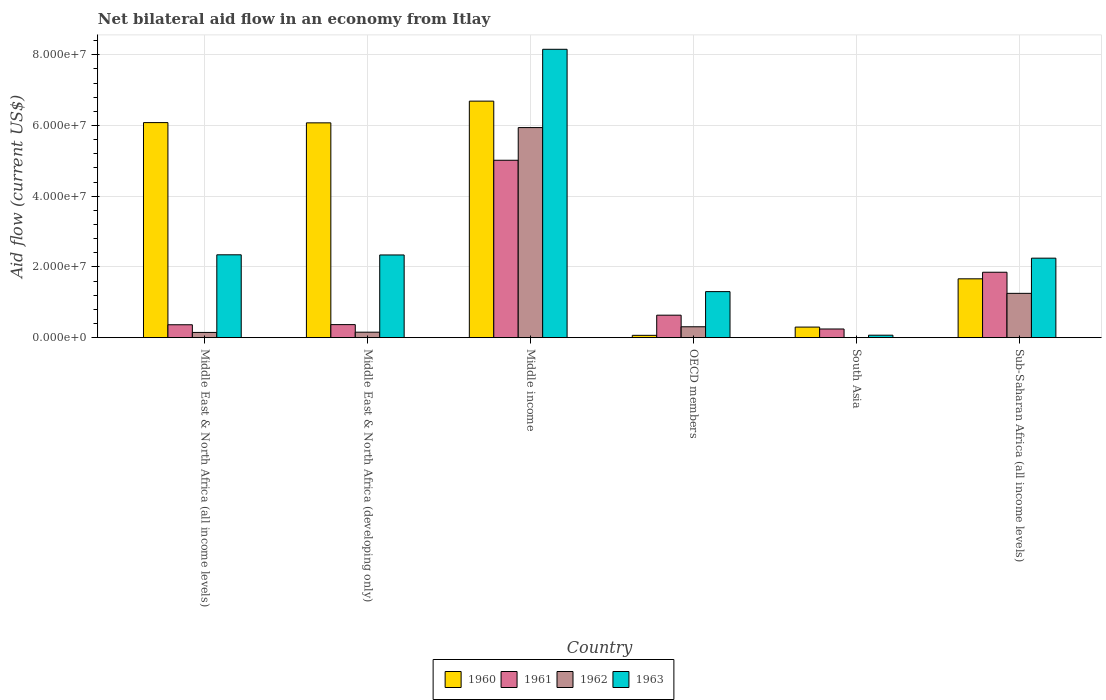How many different coloured bars are there?
Your response must be concise. 4. Are the number of bars per tick equal to the number of legend labels?
Your answer should be very brief. No. Are the number of bars on each tick of the X-axis equal?
Offer a terse response. No. How many bars are there on the 5th tick from the left?
Your answer should be very brief. 3. How many bars are there on the 6th tick from the right?
Offer a terse response. 4. What is the label of the 3rd group of bars from the left?
Give a very brief answer. Middle income. In how many cases, is the number of bars for a given country not equal to the number of legend labels?
Make the answer very short. 1. What is the net bilateral aid flow in 1960 in Middle East & North Africa (all income levels)?
Give a very brief answer. 6.08e+07. Across all countries, what is the maximum net bilateral aid flow in 1962?
Ensure brevity in your answer.  5.94e+07. In which country was the net bilateral aid flow in 1962 maximum?
Offer a very short reply. Middle income. What is the total net bilateral aid flow in 1961 in the graph?
Your answer should be compact. 8.48e+07. What is the difference between the net bilateral aid flow in 1960 in Middle income and that in South Asia?
Offer a very short reply. 6.39e+07. What is the difference between the net bilateral aid flow in 1961 in South Asia and the net bilateral aid flow in 1963 in Middle East & North Africa (developing only)?
Make the answer very short. -2.09e+07. What is the average net bilateral aid flow in 1961 per country?
Provide a succinct answer. 1.41e+07. What is the difference between the net bilateral aid flow of/in 1962 and net bilateral aid flow of/in 1963 in OECD members?
Keep it short and to the point. -9.94e+06. In how many countries, is the net bilateral aid flow in 1963 greater than 12000000 US$?
Make the answer very short. 5. What is the ratio of the net bilateral aid flow in 1961 in Middle East & North Africa (all income levels) to that in OECD members?
Your response must be concise. 0.57. What is the difference between the highest and the second highest net bilateral aid flow in 1960?
Give a very brief answer. 6.07e+06. What is the difference between the highest and the lowest net bilateral aid flow in 1961?
Provide a short and direct response. 4.77e+07. Is the sum of the net bilateral aid flow in 1961 in Middle income and Sub-Saharan Africa (all income levels) greater than the maximum net bilateral aid flow in 1963 across all countries?
Your answer should be very brief. No. Is it the case that in every country, the sum of the net bilateral aid flow in 1963 and net bilateral aid flow in 1961 is greater than the sum of net bilateral aid flow in 1962 and net bilateral aid flow in 1960?
Make the answer very short. No. Is it the case that in every country, the sum of the net bilateral aid flow in 1960 and net bilateral aid flow in 1962 is greater than the net bilateral aid flow in 1963?
Ensure brevity in your answer.  No. How many bars are there?
Offer a terse response. 23. Are all the bars in the graph horizontal?
Keep it short and to the point. No. What is the difference between two consecutive major ticks on the Y-axis?
Your answer should be compact. 2.00e+07. Are the values on the major ticks of Y-axis written in scientific E-notation?
Your answer should be very brief. Yes. Where does the legend appear in the graph?
Offer a terse response. Bottom center. How many legend labels are there?
Your answer should be very brief. 4. What is the title of the graph?
Give a very brief answer. Net bilateral aid flow in an economy from Itlay. What is the Aid flow (current US$) in 1960 in Middle East & North Africa (all income levels)?
Ensure brevity in your answer.  6.08e+07. What is the Aid flow (current US$) of 1961 in Middle East & North Africa (all income levels)?
Provide a succinct answer. 3.65e+06. What is the Aid flow (current US$) in 1962 in Middle East & North Africa (all income levels)?
Your answer should be compact. 1.48e+06. What is the Aid flow (current US$) of 1963 in Middle East & North Africa (all income levels)?
Keep it short and to the point. 2.34e+07. What is the Aid flow (current US$) in 1960 in Middle East & North Africa (developing only)?
Offer a terse response. 6.08e+07. What is the Aid flow (current US$) of 1961 in Middle East & North Africa (developing only)?
Keep it short and to the point. 3.69e+06. What is the Aid flow (current US$) of 1962 in Middle East & North Africa (developing only)?
Provide a short and direct response. 1.55e+06. What is the Aid flow (current US$) in 1963 in Middle East & North Africa (developing only)?
Provide a short and direct response. 2.34e+07. What is the Aid flow (current US$) in 1960 in Middle income?
Give a very brief answer. 6.69e+07. What is the Aid flow (current US$) of 1961 in Middle income?
Ensure brevity in your answer.  5.02e+07. What is the Aid flow (current US$) in 1962 in Middle income?
Keep it short and to the point. 5.94e+07. What is the Aid flow (current US$) of 1963 in Middle income?
Your answer should be compact. 8.16e+07. What is the Aid flow (current US$) of 1961 in OECD members?
Ensure brevity in your answer.  6.36e+06. What is the Aid flow (current US$) in 1962 in OECD members?
Your response must be concise. 3.08e+06. What is the Aid flow (current US$) of 1963 in OECD members?
Ensure brevity in your answer.  1.30e+07. What is the Aid flow (current US$) in 1960 in South Asia?
Keep it short and to the point. 2.99e+06. What is the Aid flow (current US$) of 1961 in South Asia?
Your response must be concise. 2.45e+06. What is the Aid flow (current US$) of 1962 in South Asia?
Keep it short and to the point. 0. What is the Aid flow (current US$) of 1960 in Sub-Saharan Africa (all income levels)?
Ensure brevity in your answer.  1.66e+07. What is the Aid flow (current US$) of 1961 in Sub-Saharan Africa (all income levels)?
Provide a short and direct response. 1.85e+07. What is the Aid flow (current US$) of 1962 in Sub-Saharan Africa (all income levels)?
Provide a short and direct response. 1.25e+07. What is the Aid flow (current US$) in 1963 in Sub-Saharan Africa (all income levels)?
Your answer should be compact. 2.25e+07. Across all countries, what is the maximum Aid flow (current US$) in 1960?
Your response must be concise. 6.69e+07. Across all countries, what is the maximum Aid flow (current US$) of 1961?
Provide a short and direct response. 5.02e+07. Across all countries, what is the maximum Aid flow (current US$) of 1962?
Provide a short and direct response. 5.94e+07. Across all countries, what is the maximum Aid flow (current US$) in 1963?
Your answer should be very brief. 8.16e+07. Across all countries, what is the minimum Aid flow (current US$) of 1961?
Provide a succinct answer. 2.45e+06. Across all countries, what is the minimum Aid flow (current US$) in 1962?
Give a very brief answer. 0. What is the total Aid flow (current US$) of 1960 in the graph?
Offer a very short reply. 2.09e+08. What is the total Aid flow (current US$) in 1961 in the graph?
Your answer should be very brief. 8.48e+07. What is the total Aid flow (current US$) of 1962 in the graph?
Your answer should be very brief. 7.80e+07. What is the total Aid flow (current US$) of 1963 in the graph?
Your answer should be very brief. 1.65e+08. What is the difference between the Aid flow (current US$) of 1960 in Middle East & North Africa (all income levels) and that in Middle East & North Africa (developing only)?
Provide a succinct answer. 7.00e+04. What is the difference between the Aid flow (current US$) in 1962 in Middle East & North Africa (all income levels) and that in Middle East & North Africa (developing only)?
Your answer should be compact. -7.00e+04. What is the difference between the Aid flow (current US$) of 1963 in Middle East & North Africa (all income levels) and that in Middle East & North Africa (developing only)?
Provide a succinct answer. 4.00e+04. What is the difference between the Aid flow (current US$) of 1960 in Middle East & North Africa (all income levels) and that in Middle income?
Offer a terse response. -6.07e+06. What is the difference between the Aid flow (current US$) of 1961 in Middle East & North Africa (all income levels) and that in Middle income?
Provide a succinct answer. -4.65e+07. What is the difference between the Aid flow (current US$) in 1962 in Middle East & North Africa (all income levels) and that in Middle income?
Your response must be concise. -5.79e+07. What is the difference between the Aid flow (current US$) in 1963 in Middle East & North Africa (all income levels) and that in Middle income?
Offer a terse response. -5.81e+07. What is the difference between the Aid flow (current US$) of 1960 in Middle East & North Africa (all income levels) and that in OECD members?
Give a very brief answer. 6.02e+07. What is the difference between the Aid flow (current US$) of 1961 in Middle East & North Africa (all income levels) and that in OECD members?
Give a very brief answer. -2.71e+06. What is the difference between the Aid flow (current US$) of 1962 in Middle East & North Africa (all income levels) and that in OECD members?
Your answer should be compact. -1.60e+06. What is the difference between the Aid flow (current US$) of 1963 in Middle East & North Africa (all income levels) and that in OECD members?
Keep it short and to the point. 1.04e+07. What is the difference between the Aid flow (current US$) in 1960 in Middle East & North Africa (all income levels) and that in South Asia?
Your answer should be compact. 5.78e+07. What is the difference between the Aid flow (current US$) in 1961 in Middle East & North Africa (all income levels) and that in South Asia?
Your answer should be compact. 1.20e+06. What is the difference between the Aid flow (current US$) in 1963 in Middle East & North Africa (all income levels) and that in South Asia?
Keep it short and to the point. 2.27e+07. What is the difference between the Aid flow (current US$) in 1960 in Middle East & North Africa (all income levels) and that in Sub-Saharan Africa (all income levels)?
Your response must be concise. 4.42e+07. What is the difference between the Aid flow (current US$) of 1961 in Middle East & North Africa (all income levels) and that in Sub-Saharan Africa (all income levels)?
Your answer should be compact. -1.48e+07. What is the difference between the Aid flow (current US$) in 1962 in Middle East & North Africa (all income levels) and that in Sub-Saharan Africa (all income levels)?
Keep it short and to the point. -1.10e+07. What is the difference between the Aid flow (current US$) in 1963 in Middle East & North Africa (all income levels) and that in Sub-Saharan Africa (all income levels)?
Offer a terse response. 9.50e+05. What is the difference between the Aid flow (current US$) in 1960 in Middle East & North Africa (developing only) and that in Middle income?
Your answer should be compact. -6.14e+06. What is the difference between the Aid flow (current US$) in 1961 in Middle East & North Africa (developing only) and that in Middle income?
Your answer should be very brief. -4.65e+07. What is the difference between the Aid flow (current US$) in 1962 in Middle East & North Africa (developing only) and that in Middle income?
Your response must be concise. -5.79e+07. What is the difference between the Aid flow (current US$) of 1963 in Middle East & North Africa (developing only) and that in Middle income?
Make the answer very short. -5.82e+07. What is the difference between the Aid flow (current US$) of 1960 in Middle East & North Africa (developing only) and that in OECD members?
Ensure brevity in your answer.  6.01e+07. What is the difference between the Aid flow (current US$) in 1961 in Middle East & North Africa (developing only) and that in OECD members?
Keep it short and to the point. -2.67e+06. What is the difference between the Aid flow (current US$) of 1962 in Middle East & North Africa (developing only) and that in OECD members?
Give a very brief answer. -1.53e+06. What is the difference between the Aid flow (current US$) in 1963 in Middle East & North Africa (developing only) and that in OECD members?
Ensure brevity in your answer.  1.04e+07. What is the difference between the Aid flow (current US$) of 1960 in Middle East & North Africa (developing only) and that in South Asia?
Ensure brevity in your answer.  5.78e+07. What is the difference between the Aid flow (current US$) of 1961 in Middle East & North Africa (developing only) and that in South Asia?
Ensure brevity in your answer.  1.24e+06. What is the difference between the Aid flow (current US$) in 1963 in Middle East & North Africa (developing only) and that in South Asia?
Your response must be concise. 2.27e+07. What is the difference between the Aid flow (current US$) of 1960 in Middle East & North Africa (developing only) and that in Sub-Saharan Africa (all income levels)?
Your answer should be compact. 4.41e+07. What is the difference between the Aid flow (current US$) in 1961 in Middle East & North Africa (developing only) and that in Sub-Saharan Africa (all income levels)?
Provide a succinct answer. -1.48e+07. What is the difference between the Aid flow (current US$) in 1962 in Middle East & North Africa (developing only) and that in Sub-Saharan Africa (all income levels)?
Keep it short and to the point. -1.10e+07. What is the difference between the Aid flow (current US$) in 1963 in Middle East & North Africa (developing only) and that in Sub-Saharan Africa (all income levels)?
Offer a terse response. 9.10e+05. What is the difference between the Aid flow (current US$) of 1960 in Middle income and that in OECD members?
Make the answer very short. 6.62e+07. What is the difference between the Aid flow (current US$) of 1961 in Middle income and that in OECD members?
Offer a very short reply. 4.38e+07. What is the difference between the Aid flow (current US$) of 1962 in Middle income and that in OECD members?
Provide a short and direct response. 5.63e+07. What is the difference between the Aid flow (current US$) of 1963 in Middle income and that in OECD members?
Your response must be concise. 6.85e+07. What is the difference between the Aid flow (current US$) in 1960 in Middle income and that in South Asia?
Give a very brief answer. 6.39e+07. What is the difference between the Aid flow (current US$) in 1961 in Middle income and that in South Asia?
Give a very brief answer. 4.77e+07. What is the difference between the Aid flow (current US$) of 1963 in Middle income and that in South Asia?
Provide a short and direct response. 8.08e+07. What is the difference between the Aid flow (current US$) of 1960 in Middle income and that in Sub-Saharan Africa (all income levels)?
Keep it short and to the point. 5.02e+07. What is the difference between the Aid flow (current US$) in 1961 in Middle income and that in Sub-Saharan Africa (all income levels)?
Offer a terse response. 3.17e+07. What is the difference between the Aid flow (current US$) of 1962 in Middle income and that in Sub-Saharan Africa (all income levels)?
Offer a terse response. 4.69e+07. What is the difference between the Aid flow (current US$) in 1963 in Middle income and that in Sub-Saharan Africa (all income levels)?
Offer a very short reply. 5.91e+07. What is the difference between the Aid flow (current US$) in 1960 in OECD members and that in South Asia?
Keep it short and to the point. -2.33e+06. What is the difference between the Aid flow (current US$) of 1961 in OECD members and that in South Asia?
Make the answer very short. 3.91e+06. What is the difference between the Aid flow (current US$) of 1963 in OECD members and that in South Asia?
Offer a terse response. 1.23e+07. What is the difference between the Aid flow (current US$) in 1960 in OECD members and that in Sub-Saharan Africa (all income levels)?
Give a very brief answer. -1.60e+07. What is the difference between the Aid flow (current US$) of 1961 in OECD members and that in Sub-Saharan Africa (all income levels)?
Your response must be concise. -1.21e+07. What is the difference between the Aid flow (current US$) in 1962 in OECD members and that in Sub-Saharan Africa (all income levels)?
Ensure brevity in your answer.  -9.45e+06. What is the difference between the Aid flow (current US$) of 1963 in OECD members and that in Sub-Saharan Africa (all income levels)?
Your answer should be very brief. -9.46e+06. What is the difference between the Aid flow (current US$) in 1960 in South Asia and that in Sub-Saharan Africa (all income levels)?
Keep it short and to the point. -1.36e+07. What is the difference between the Aid flow (current US$) in 1961 in South Asia and that in Sub-Saharan Africa (all income levels)?
Your answer should be compact. -1.60e+07. What is the difference between the Aid flow (current US$) of 1963 in South Asia and that in Sub-Saharan Africa (all income levels)?
Ensure brevity in your answer.  -2.18e+07. What is the difference between the Aid flow (current US$) in 1960 in Middle East & North Africa (all income levels) and the Aid flow (current US$) in 1961 in Middle East & North Africa (developing only)?
Provide a short and direct response. 5.71e+07. What is the difference between the Aid flow (current US$) of 1960 in Middle East & North Africa (all income levels) and the Aid flow (current US$) of 1962 in Middle East & North Africa (developing only)?
Provide a short and direct response. 5.93e+07. What is the difference between the Aid flow (current US$) in 1960 in Middle East & North Africa (all income levels) and the Aid flow (current US$) in 1963 in Middle East & North Africa (developing only)?
Keep it short and to the point. 3.74e+07. What is the difference between the Aid flow (current US$) in 1961 in Middle East & North Africa (all income levels) and the Aid flow (current US$) in 1962 in Middle East & North Africa (developing only)?
Give a very brief answer. 2.10e+06. What is the difference between the Aid flow (current US$) in 1961 in Middle East & North Africa (all income levels) and the Aid flow (current US$) in 1963 in Middle East & North Africa (developing only)?
Make the answer very short. -1.97e+07. What is the difference between the Aid flow (current US$) of 1962 in Middle East & North Africa (all income levels) and the Aid flow (current US$) of 1963 in Middle East & North Africa (developing only)?
Provide a succinct answer. -2.19e+07. What is the difference between the Aid flow (current US$) in 1960 in Middle East & North Africa (all income levels) and the Aid flow (current US$) in 1961 in Middle income?
Your response must be concise. 1.06e+07. What is the difference between the Aid flow (current US$) of 1960 in Middle East & North Africa (all income levels) and the Aid flow (current US$) of 1962 in Middle income?
Your answer should be very brief. 1.41e+06. What is the difference between the Aid flow (current US$) of 1960 in Middle East & North Africa (all income levels) and the Aid flow (current US$) of 1963 in Middle income?
Provide a succinct answer. -2.07e+07. What is the difference between the Aid flow (current US$) of 1961 in Middle East & North Africa (all income levels) and the Aid flow (current US$) of 1962 in Middle income?
Your answer should be very brief. -5.58e+07. What is the difference between the Aid flow (current US$) in 1961 in Middle East & North Africa (all income levels) and the Aid flow (current US$) in 1963 in Middle income?
Make the answer very short. -7.79e+07. What is the difference between the Aid flow (current US$) of 1962 in Middle East & North Africa (all income levels) and the Aid flow (current US$) of 1963 in Middle income?
Your answer should be compact. -8.01e+07. What is the difference between the Aid flow (current US$) of 1960 in Middle East & North Africa (all income levels) and the Aid flow (current US$) of 1961 in OECD members?
Keep it short and to the point. 5.45e+07. What is the difference between the Aid flow (current US$) of 1960 in Middle East & North Africa (all income levels) and the Aid flow (current US$) of 1962 in OECD members?
Your answer should be very brief. 5.77e+07. What is the difference between the Aid flow (current US$) of 1960 in Middle East & North Africa (all income levels) and the Aid flow (current US$) of 1963 in OECD members?
Offer a very short reply. 4.78e+07. What is the difference between the Aid flow (current US$) of 1961 in Middle East & North Africa (all income levels) and the Aid flow (current US$) of 1962 in OECD members?
Offer a very short reply. 5.70e+05. What is the difference between the Aid flow (current US$) in 1961 in Middle East & North Africa (all income levels) and the Aid flow (current US$) in 1963 in OECD members?
Make the answer very short. -9.37e+06. What is the difference between the Aid flow (current US$) of 1962 in Middle East & North Africa (all income levels) and the Aid flow (current US$) of 1963 in OECD members?
Your answer should be very brief. -1.15e+07. What is the difference between the Aid flow (current US$) in 1960 in Middle East & North Africa (all income levels) and the Aid flow (current US$) in 1961 in South Asia?
Provide a succinct answer. 5.84e+07. What is the difference between the Aid flow (current US$) of 1960 in Middle East & North Africa (all income levels) and the Aid flow (current US$) of 1963 in South Asia?
Offer a very short reply. 6.01e+07. What is the difference between the Aid flow (current US$) in 1961 in Middle East & North Africa (all income levels) and the Aid flow (current US$) in 1963 in South Asia?
Offer a terse response. 2.95e+06. What is the difference between the Aid flow (current US$) in 1962 in Middle East & North Africa (all income levels) and the Aid flow (current US$) in 1963 in South Asia?
Make the answer very short. 7.80e+05. What is the difference between the Aid flow (current US$) in 1960 in Middle East & North Africa (all income levels) and the Aid flow (current US$) in 1961 in Sub-Saharan Africa (all income levels)?
Give a very brief answer. 4.23e+07. What is the difference between the Aid flow (current US$) in 1960 in Middle East & North Africa (all income levels) and the Aid flow (current US$) in 1962 in Sub-Saharan Africa (all income levels)?
Your answer should be very brief. 4.83e+07. What is the difference between the Aid flow (current US$) in 1960 in Middle East & North Africa (all income levels) and the Aid flow (current US$) in 1963 in Sub-Saharan Africa (all income levels)?
Offer a very short reply. 3.83e+07. What is the difference between the Aid flow (current US$) of 1961 in Middle East & North Africa (all income levels) and the Aid flow (current US$) of 1962 in Sub-Saharan Africa (all income levels)?
Your answer should be very brief. -8.88e+06. What is the difference between the Aid flow (current US$) in 1961 in Middle East & North Africa (all income levels) and the Aid flow (current US$) in 1963 in Sub-Saharan Africa (all income levels)?
Give a very brief answer. -1.88e+07. What is the difference between the Aid flow (current US$) in 1962 in Middle East & North Africa (all income levels) and the Aid flow (current US$) in 1963 in Sub-Saharan Africa (all income levels)?
Provide a succinct answer. -2.10e+07. What is the difference between the Aid flow (current US$) of 1960 in Middle East & North Africa (developing only) and the Aid flow (current US$) of 1961 in Middle income?
Provide a short and direct response. 1.06e+07. What is the difference between the Aid flow (current US$) in 1960 in Middle East & North Africa (developing only) and the Aid flow (current US$) in 1962 in Middle income?
Your answer should be compact. 1.34e+06. What is the difference between the Aid flow (current US$) of 1960 in Middle East & North Africa (developing only) and the Aid flow (current US$) of 1963 in Middle income?
Ensure brevity in your answer.  -2.08e+07. What is the difference between the Aid flow (current US$) of 1961 in Middle East & North Africa (developing only) and the Aid flow (current US$) of 1962 in Middle income?
Your response must be concise. -5.57e+07. What is the difference between the Aid flow (current US$) in 1961 in Middle East & North Africa (developing only) and the Aid flow (current US$) in 1963 in Middle income?
Keep it short and to the point. -7.79e+07. What is the difference between the Aid flow (current US$) in 1962 in Middle East & North Africa (developing only) and the Aid flow (current US$) in 1963 in Middle income?
Your response must be concise. -8.00e+07. What is the difference between the Aid flow (current US$) in 1960 in Middle East & North Africa (developing only) and the Aid flow (current US$) in 1961 in OECD members?
Give a very brief answer. 5.44e+07. What is the difference between the Aid flow (current US$) in 1960 in Middle East & North Africa (developing only) and the Aid flow (current US$) in 1962 in OECD members?
Provide a succinct answer. 5.77e+07. What is the difference between the Aid flow (current US$) in 1960 in Middle East & North Africa (developing only) and the Aid flow (current US$) in 1963 in OECD members?
Your answer should be compact. 4.77e+07. What is the difference between the Aid flow (current US$) of 1961 in Middle East & North Africa (developing only) and the Aid flow (current US$) of 1962 in OECD members?
Ensure brevity in your answer.  6.10e+05. What is the difference between the Aid flow (current US$) in 1961 in Middle East & North Africa (developing only) and the Aid flow (current US$) in 1963 in OECD members?
Make the answer very short. -9.33e+06. What is the difference between the Aid flow (current US$) of 1962 in Middle East & North Africa (developing only) and the Aid flow (current US$) of 1963 in OECD members?
Your answer should be very brief. -1.15e+07. What is the difference between the Aid flow (current US$) of 1960 in Middle East & North Africa (developing only) and the Aid flow (current US$) of 1961 in South Asia?
Your answer should be very brief. 5.83e+07. What is the difference between the Aid flow (current US$) in 1960 in Middle East & North Africa (developing only) and the Aid flow (current US$) in 1963 in South Asia?
Provide a short and direct response. 6.00e+07. What is the difference between the Aid flow (current US$) of 1961 in Middle East & North Africa (developing only) and the Aid flow (current US$) of 1963 in South Asia?
Make the answer very short. 2.99e+06. What is the difference between the Aid flow (current US$) in 1962 in Middle East & North Africa (developing only) and the Aid flow (current US$) in 1963 in South Asia?
Make the answer very short. 8.50e+05. What is the difference between the Aid flow (current US$) in 1960 in Middle East & North Africa (developing only) and the Aid flow (current US$) in 1961 in Sub-Saharan Africa (all income levels)?
Your answer should be very brief. 4.22e+07. What is the difference between the Aid flow (current US$) of 1960 in Middle East & North Africa (developing only) and the Aid flow (current US$) of 1962 in Sub-Saharan Africa (all income levels)?
Offer a very short reply. 4.82e+07. What is the difference between the Aid flow (current US$) of 1960 in Middle East & North Africa (developing only) and the Aid flow (current US$) of 1963 in Sub-Saharan Africa (all income levels)?
Make the answer very short. 3.83e+07. What is the difference between the Aid flow (current US$) of 1961 in Middle East & North Africa (developing only) and the Aid flow (current US$) of 1962 in Sub-Saharan Africa (all income levels)?
Your answer should be very brief. -8.84e+06. What is the difference between the Aid flow (current US$) of 1961 in Middle East & North Africa (developing only) and the Aid flow (current US$) of 1963 in Sub-Saharan Africa (all income levels)?
Give a very brief answer. -1.88e+07. What is the difference between the Aid flow (current US$) of 1962 in Middle East & North Africa (developing only) and the Aid flow (current US$) of 1963 in Sub-Saharan Africa (all income levels)?
Make the answer very short. -2.09e+07. What is the difference between the Aid flow (current US$) of 1960 in Middle income and the Aid flow (current US$) of 1961 in OECD members?
Give a very brief answer. 6.05e+07. What is the difference between the Aid flow (current US$) of 1960 in Middle income and the Aid flow (current US$) of 1962 in OECD members?
Offer a very short reply. 6.38e+07. What is the difference between the Aid flow (current US$) of 1960 in Middle income and the Aid flow (current US$) of 1963 in OECD members?
Provide a succinct answer. 5.39e+07. What is the difference between the Aid flow (current US$) in 1961 in Middle income and the Aid flow (current US$) in 1962 in OECD members?
Offer a terse response. 4.71e+07. What is the difference between the Aid flow (current US$) of 1961 in Middle income and the Aid flow (current US$) of 1963 in OECD members?
Make the answer very short. 3.72e+07. What is the difference between the Aid flow (current US$) in 1962 in Middle income and the Aid flow (current US$) in 1963 in OECD members?
Your answer should be compact. 4.64e+07. What is the difference between the Aid flow (current US$) in 1960 in Middle income and the Aid flow (current US$) in 1961 in South Asia?
Your response must be concise. 6.44e+07. What is the difference between the Aid flow (current US$) in 1960 in Middle income and the Aid flow (current US$) in 1963 in South Asia?
Your answer should be very brief. 6.62e+07. What is the difference between the Aid flow (current US$) of 1961 in Middle income and the Aid flow (current US$) of 1963 in South Asia?
Your answer should be very brief. 4.95e+07. What is the difference between the Aid flow (current US$) in 1962 in Middle income and the Aid flow (current US$) in 1963 in South Asia?
Your answer should be compact. 5.87e+07. What is the difference between the Aid flow (current US$) of 1960 in Middle income and the Aid flow (current US$) of 1961 in Sub-Saharan Africa (all income levels)?
Your answer should be compact. 4.84e+07. What is the difference between the Aid flow (current US$) in 1960 in Middle income and the Aid flow (current US$) in 1962 in Sub-Saharan Africa (all income levels)?
Your response must be concise. 5.44e+07. What is the difference between the Aid flow (current US$) of 1960 in Middle income and the Aid flow (current US$) of 1963 in Sub-Saharan Africa (all income levels)?
Offer a terse response. 4.44e+07. What is the difference between the Aid flow (current US$) in 1961 in Middle income and the Aid flow (current US$) in 1962 in Sub-Saharan Africa (all income levels)?
Give a very brief answer. 3.76e+07. What is the difference between the Aid flow (current US$) in 1961 in Middle income and the Aid flow (current US$) in 1963 in Sub-Saharan Africa (all income levels)?
Keep it short and to the point. 2.77e+07. What is the difference between the Aid flow (current US$) of 1962 in Middle income and the Aid flow (current US$) of 1963 in Sub-Saharan Africa (all income levels)?
Offer a very short reply. 3.69e+07. What is the difference between the Aid flow (current US$) in 1960 in OECD members and the Aid flow (current US$) in 1961 in South Asia?
Offer a terse response. -1.79e+06. What is the difference between the Aid flow (current US$) of 1960 in OECD members and the Aid flow (current US$) of 1963 in South Asia?
Keep it short and to the point. -4.00e+04. What is the difference between the Aid flow (current US$) of 1961 in OECD members and the Aid flow (current US$) of 1963 in South Asia?
Provide a short and direct response. 5.66e+06. What is the difference between the Aid flow (current US$) in 1962 in OECD members and the Aid flow (current US$) in 1963 in South Asia?
Keep it short and to the point. 2.38e+06. What is the difference between the Aid flow (current US$) of 1960 in OECD members and the Aid flow (current US$) of 1961 in Sub-Saharan Africa (all income levels)?
Your answer should be very brief. -1.78e+07. What is the difference between the Aid flow (current US$) of 1960 in OECD members and the Aid flow (current US$) of 1962 in Sub-Saharan Africa (all income levels)?
Your answer should be compact. -1.19e+07. What is the difference between the Aid flow (current US$) of 1960 in OECD members and the Aid flow (current US$) of 1963 in Sub-Saharan Africa (all income levels)?
Offer a very short reply. -2.18e+07. What is the difference between the Aid flow (current US$) in 1961 in OECD members and the Aid flow (current US$) in 1962 in Sub-Saharan Africa (all income levels)?
Give a very brief answer. -6.17e+06. What is the difference between the Aid flow (current US$) in 1961 in OECD members and the Aid flow (current US$) in 1963 in Sub-Saharan Africa (all income levels)?
Offer a very short reply. -1.61e+07. What is the difference between the Aid flow (current US$) in 1962 in OECD members and the Aid flow (current US$) in 1963 in Sub-Saharan Africa (all income levels)?
Your answer should be compact. -1.94e+07. What is the difference between the Aid flow (current US$) in 1960 in South Asia and the Aid flow (current US$) in 1961 in Sub-Saharan Africa (all income levels)?
Your response must be concise. -1.55e+07. What is the difference between the Aid flow (current US$) of 1960 in South Asia and the Aid flow (current US$) of 1962 in Sub-Saharan Africa (all income levels)?
Ensure brevity in your answer.  -9.54e+06. What is the difference between the Aid flow (current US$) in 1960 in South Asia and the Aid flow (current US$) in 1963 in Sub-Saharan Africa (all income levels)?
Make the answer very short. -1.95e+07. What is the difference between the Aid flow (current US$) of 1961 in South Asia and the Aid flow (current US$) of 1962 in Sub-Saharan Africa (all income levels)?
Your response must be concise. -1.01e+07. What is the difference between the Aid flow (current US$) in 1961 in South Asia and the Aid flow (current US$) in 1963 in Sub-Saharan Africa (all income levels)?
Your answer should be compact. -2.00e+07. What is the average Aid flow (current US$) in 1960 per country?
Give a very brief answer. 3.48e+07. What is the average Aid flow (current US$) in 1961 per country?
Your answer should be compact. 1.41e+07. What is the average Aid flow (current US$) in 1962 per country?
Your answer should be compact. 1.30e+07. What is the average Aid flow (current US$) in 1963 per country?
Offer a terse response. 2.74e+07. What is the difference between the Aid flow (current US$) in 1960 and Aid flow (current US$) in 1961 in Middle East & North Africa (all income levels)?
Give a very brief answer. 5.72e+07. What is the difference between the Aid flow (current US$) of 1960 and Aid flow (current US$) of 1962 in Middle East & North Africa (all income levels)?
Provide a succinct answer. 5.93e+07. What is the difference between the Aid flow (current US$) in 1960 and Aid flow (current US$) in 1963 in Middle East & North Africa (all income levels)?
Offer a terse response. 3.74e+07. What is the difference between the Aid flow (current US$) of 1961 and Aid flow (current US$) of 1962 in Middle East & North Africa (all income levels)?
Give a very brief answer. 2.17e+06. What is the difference between the Aid flow (current US$) in 1961 and Aid flow (current US$) in 1963 in Middle East & North Africa (all income levels)?
Ensure brevity in your answer.  -1.98e+07. What is the difference between the Aid flow (current US$) in 1962 and Aid flow (current US$) in 1963 in Middle East & North Africa (all income levels)?
Your answer should be compact. -2.20e+07. What is the difference between the Aid flow (current US$) of 1960 and Aid flow (current US$) of 1961 in Middle East & North Africa (developing only)?
Provide a short and direct response. 5.71e+07. What is the difference between the Aid flow (current US$) of 1960 and Aid flow (current US$) of 1962 in Middle East & North Africa (developing only)?
Your response must be concise. 5.92e+07. What is the difference between the Aid flow (current US$) in 1960 and Aid flow (current US$) in 1963 in Middle East & North Africa (developing only)?
Your answer should be very brief. 3.74e+07. What is the difference between the Aid flow (current US$) of 1961 and Aid flow (current US$) of 1962 in Middle East & North Africa (developing only)?
Provide a short and direct response. 2.14e+06. What is the difference between the Aid flow (current US$) of 1961 and Aid flow (current US$) of 1963 in Middle East & North Africa (developing only)?
Your answer should be very brief. -1.97e+07. What is the difference between the Aid flow (current US$) of 1962 and Aid flow (current US$) of 1963 in Middle East & North Africa (developing only)?
Make the answer very short. -2.18e+07. What is the difference between the Aid flow (current US$) in 1960 and Aid flow (current US$) in 1961 in Middle income?
Ensure brevity in your answer.  1.67e+07. What is the difference between the Aid flow (current US$) in 1960 and Aid flow (current US$) in 1962 in Middle income?
Provide a succinct answer. 7.48e+06. What is the difference between the Aid flow (current US$) in 1960 and Aid flow (current US$) in 1963 in Middle income?
Your answer should be compact. -1.47e+07. What is the difference between the Aid flow (current US$) of 1961 and Aid flow (current US$) of 1962 in Middle income?
Give a very brief answer. -9.24e+06. What is the difference between the Aid flow (current US$) of 1961 and Aid flow (current US$) of 1963 in Middle income?
Provide a succinct answer. -3.14e+07. What is the difference between the Aid flow (current US$) in 1962 and Aid flow (current US$) in 1963 in Middle income?
Offer a very short reply. -2.21e+07. What is the difference between the Aid flow (current US$) of 1960 and Aid flow (current US$) of 1961 in OECD members?
Your answer should be compact. -5.70e+06. What is the difference between the Aid flow (current US$) in 1960 and Aid flow (current US$) in 1962 in OECD members?
Provide a short and direct response. -2.42e+06. What is the difference between the Aid flow (current US$) in 1960 and Aid flow (current US$) in 1963 in OECD members?
Make the answer very short. -1.24e+07. What is the difference between the Aid flow (current US$) of 1961 and Aid flow (current US$) of 1962 in OECD members?
Your answer should be very brief. 3.28e+06. What is the difference between the Aid flow (current US$) of 1961 and Aid flow (current US$) of 1963 in OECD members?
Keep it short and to the point. -6.66e+06. What is the difference between the Aid flow (current US$) in 1962 and Aid flow (current US$) in 1963 in OECD members?
Your response must be concise. -9.94e+06. What is the difference between the Aid flow (current US$) of 1960 and Aid flow (current US$) of 1961 in South Asia?
Make the answer very short. 5.40e+05. What is the difference between the Aid flow (current US$) of 1960 and Aid flow (current US$) of 1963 in South Asia?
Make the answer very short. 2.29e+06. What is the difference between the Aid flow (current US$) in 1961 and Aid flow (current US$) in 1963 in South Asia?
Your answer should be compact. 1.75e+06. What is the difference between the Aid flow (current US$) in 1960 and Aid flow (current US$) in 1961 in Sub-Saharan Africa (all income levels)?
Make the answer very short. -1.86e+06. What is the difference between the Aid flow (current US$) in 1960 and Aid flow (current US$) in 1962 in Sub-Saharan Africa (all income levels)?
Give a very brief answer. 4.11e+06. What is the difference between the Aid flow (current US$) of 1960 and Aid flow (current US$) of 1963 in Sub-Saharan Africa (all income levels)?
Your answer should be very brief. -5.84e+06. What is the difference between the Aid flow (current US$) in 1961 and Aid flow (current US$) in 1962 in Sub-Saharan Africa (all income levels)?
Your response must be concise. 5.97e+06. What is the difference between the Aid flow (current US$) in 1961 and Aid flow (current US$) in 1963 in Sub-Saharan Africa (all income levels)?
Offer a terse response. -3.98e+06. What is the difference between the Aid flow (current US$) in 1962 and Aid flow (current US$) in 1963 in Sub-Saharan Africa (all income levels)?
Make the answer very short. -9.95e+06. What is the ratio of the Aid flow (current US$) of 1961 in Middle East & North Africa (all income levels) to that in Middle East & North Africa (developing only)?
Offer a very short reply. 0.99. What is the ratio of the Aid flow (current US$) of 1962 in Middle East & North Africa (all income levels) to that in Middle East & North Africa (developing only)?
Offer a terse response. 0.95. What is the ratio of the Aid flow (current US$) of 1960 in Middle East & North Africa (all income levels) to that in Middle income?
Keep it short and to the point. 0.91. What is the ratio of the Aid flow (current US$) of 1961 in Middle East & North Africa (all income levels) to that in Middle income?
Your response must be concise. 0.07. What is the ratio of the Aid flow (current US$) of 1962 in Middle East & North Africa (all income levels) to that in Middle income?
Ensure brevity in your answer.  0.02. What is the ratio of the Aid flow (current US$) in 1963 in Middle East & North Africa (all income levels) to that in Middle income?
Ensure brevity in your answer.  0.29. What is the ratio of the Aid flow (current US$) in 1960 in Middle East & North Africa (all income levels) to that in OECD members?
Make the answer very short. 92.15. What is the ratio of the Aid flow (current US$) of 1961 in Middle East & North Africa (all income levels) to that in OECD members?
Your answer should be very brief. 0.57. What is the ratio of the Aid flow (current US$) of 1962 in Middle East & North Africa (all income levels) to that in OECD members?
Your answer should be compact. 0.48. What is the ratio of the Aid flow (current US$) in 1963 in Middle East & North Africa (all income levels) to that in OECD members?
Make the answer very short. 1.8. What is the ratio of the Aid flow (current US$) in 1960 in Middle East & North Africa (all income levels) to that in South Asia?
Your answer should be very brief. 20.34. What is the ratio of the Aid flow (current US$) of 1961 in Middle East & North Africa (all income levels) to that in South Asia?
Offer a very short reply. 1.49. What is the ratio of the Aid flow (current US$) in 1963 in Middle East & North Africa (all income levels) to that in South Asia?
Keep it short and to the point. 33.47. What is the ratio of the Aid flow (current US$) in 1960 in Middle East & North Africa (all income levels) to that in Sub-Saharan Africa (all income levels)?
Make the answer very short. 3.65. What is the ratio of the Aid flow (current US$) in 1961 in Middle East & North Africa (all income levels) to that in Sub-Saharan Africa (all income levels)?
Keep it short and to the point. 0.2. What is the ratio of the Aid flow (current US$) of 1962 in Middle East & North Africa (all income levels) to that in Sub-Saharan Africa (all income levels)?
Your response must be concise. 0.12. What is the ratio of the Aid flow (current US$) in 1963 in Middle East & North Africa (all income levels) to that in Sub-Saharan Africa (all income levels)?
Your answer should be compact. 1.04. What is the ratio of the Aid flow (current US$) in 1960 in Middle East & North Africa (developing only) to that in Middle income?
Offer a very short reply. 0.91. What is the ratio of the Aid flow (current US$) in 1961 in Middle East & North Africa (developing only) to that in Middle income?
Offer a terse response. 0.07. What is the ratio of the Aid flow (current US$) in 1962 in Middle East & North Africa (developing only) to that in Middle income?
Offer a terse response. 0.03. What is the ratio of the Aid flow (current US$) of 1963 in Middle East & North Africa (developing only) to that in Middle income?
Make the answer very short. 0.29. What is the ratio of the Aid flow (current US$) in 1960 in Middle East & North Africa (developing only) to that in OECD members?
Offer a terse response. 92.05. What is the ratio of the Aid flow (current US$) of 1961 in Middle East & North Africa (developing only) to that in OECD members?
Provide a short and direct response. 0.58. What is the ratio of the Aid flow (current US$) of 1962 in Middle East & North Africa (developing only) to that in OECD members?
Provide a succinct answer. 0.5. What is the ratio of the Aid flow (current US$) in 1963 in Middle East & North Africa (developing only) to that in OECD members?
Offer a very short reply. 1.8. What is the ratio of the Aid flow (current US$) in 1960 in Middle East & North Africa (developing only) to that in South Asia?
Your response must be concise. 20.32. What is the ratio of the Aid flow (current US$) in 1961 in Middle East & North Africa (developing only) to that in South Asia?
Ensure brevity in your answer.  1.51. What is the ratio of the Aid flow (current US$) of 1963 in Middle East & North Africa (developing only) to that in South Asia?
Make the answer very short. 33.41. What is the ratio of the Aid flow (current US$) in 1960 in Middle East & North Africa (developing only) to that in Sub-Saharan Africa (all income levels)?
Your answer should be very brief. 3.65. What is the ratio of the Aid flow (current US$) in 1961 in Middle East & North Africa (developing only) to that in Sub-Saharan Africa (all income levels)?
Provide a succinct answer. 0.2. What is the ratio of the Aid flow (current US$) in 1962 in Middle East & North Africa (developing only) to that in Sub-Saharan Africa (all income levels)?
Give a very brief answer. 0.12. What is the ratio of the Aid flow (current US$) of 1963 in Middle East & North Africa (developing only) to that in Sub-Saharan Africa (all income levels)?
Offer a terse response. 1.04. What is the ratio of the Aid flow (current US$) in 1960 in Middle income to that in OECD members?
Offer a terse response. 101.35. What is the ratio of the Aid flow (current US$) of 1961 in Middle income to that in OECD members?
Provide a short and direct response. 7.89. What is the ratio of the Aid flow (current US$) of 1962 in Middle income to that in OECD members?
Make the answer very short. 19.29. What is the ratio of the Aid flow (current US$) of 1963 in Middle income to that in OECD members?
Give a very brief answer. 6.26. What is the ratio of the Aid flow (current US$) of 1960 in Middle income to that in South Asia?
Offer a terse response. 22.37. What is the ratio of the Aid flow (current US$) in 1961 in Middle income to that in South Asia?
Offer a terse response. 20.48. What is the ratio of the Aid flow (current US$) of 1963 in Middle income to that in South Asia?
Give a very brief answer. 116.5. What is the ratio of the Aid flow (current US$) in 1960 in Middle income to that in Sub-Saharan Africa (all income levels)?
Your answer should be compact. 4.02. What is the ratio of the Aid flow (current US$) of 1961 in Middle income to that in Sub-Saharan Africa (all income levels)?
Your answer should be compact. 2.71. What is the ratio of the Aid flow (current US$) in 1962 in Middle income to that in Sub-Saharan Africa (all income levels)?
Provide a succinct answer. 4.74. What is the ratio of the Aid flow (current US$) of 1963 in Middle income to that in Sub-Saharan Africa (all income levels)?
Provide a succinct answer. 3.63. What is the ratio of the Aid flow (current US$) in 1960 in OECD members to that in South Asia?
Provide a short and direct response. 0.22. What is the ratio of the Aid flow (current US$) in 1961 in OECD members to that in South Asia?
Your response must be concise. 2.6. What is the ratio of the Aid flow (current US$) in 1960 in OECD members to that in Sub-Saharan Africa (all income levels)?
Ensure brevity in your answer.  0.04. What is the ratio of the Aid flow (current US$) of 1961 in OECD members to that in Sub-Saharan Africa (all income levels)?
Keep it short and to the point. 0.34. What is the ratio of the Aid flow (current US$) of 1962 in OECD members to that in Sub-Saharan Africa (all income levels)?
Keep it short and to the point. 0.25. What is the ratio of the Aid flow (current US$) in 1963 in OECD members to that in Sub-Saharan Africa (all income levels)?
Make the answer very short. 0.58. What is the ratio of the Aid flow (current US$) of 1960 in South Asia to that in Sub-Saharan Africa (all income levels)?
Offer a very short reply. 0.18. What is the ratio of the Aid flow (current US$) of 1961 in South Asia to that in Sub-Saharan Africa (all income levels)?
Offer a very short reply. 0.13. What is the ratio of the Aid flow (current US$) of 1963 in South Asia to that in Sub-Saharan Africa (all income levels)?
Your answer should be very brief. 0.03. What is the difference between the highest and the second highest Aid flow (current US$) in 1960?
Provide a succinct answer. 6.07e+06. What is the difference between the highest and the second highest Aid flow (current US$) of 1961?
Keep it short and to the point. 3.17e+07. What is the difference between the highest and the second highest Aid flow (current US$) in 1962?
Make the answer very short. 4.69e+07. What is the difference between the highest and the second highest Aid flow (current US$) of 1963?
Keep it short and to the point. 5.81e+07. What is the difference between the highest and the lowest Aid flow (current US$) in 1960?
Provide a short and direct response. 6.62e+07. What is the difference between the highest and the lowest Aid flow (current US$) of 1961?
Keep it short and to the point. 4.77e+07. What is the difference between the highest and the lowest Aid flow (current US$) of 1962?
Your answer should be very brief. 5.94e+07. What is the difference between the highest and the lowest Aid flow (current US$) in 1963?
Your answer should be very brief. 8.08e+07. 